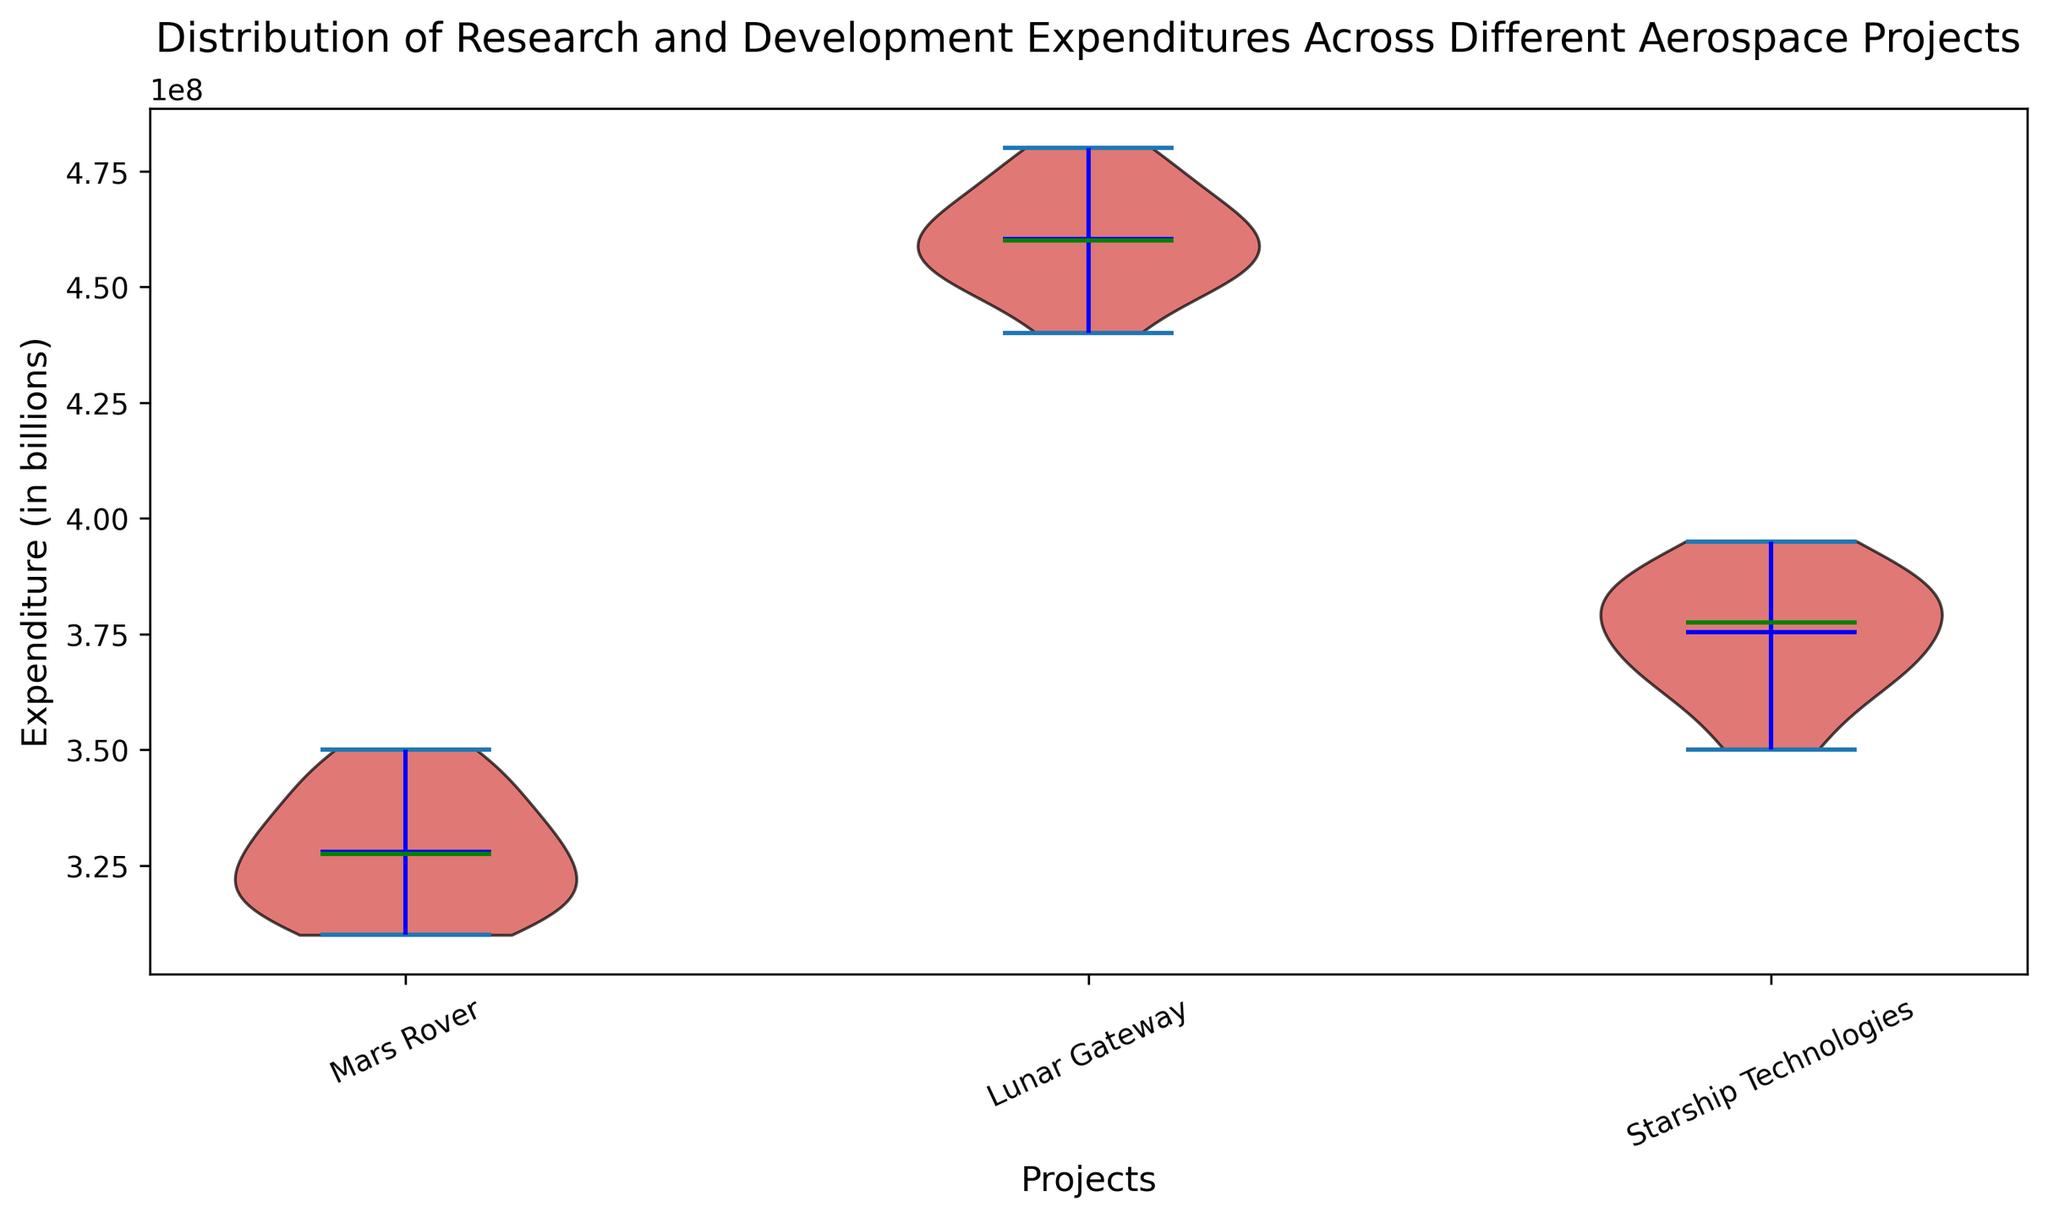What is the median expenditure for the Mars Rover project? Look for the green line that indicates the median within the violin plot section for the Mars Rover project.
Answer: $325,000,000 Which project shows the highest maximum expenditure value? Compare the heights of the violin plots for each project, particularly the uppermost points. The Lunar Gateway project has the highest uppermost point.
Answer: Lunar Gateway Does the Starship Technologies project have a higher mean expenditure than the Mars Rover project? The blue line signifies the mean expenditure. Compare the position of the blue line within the Starship Technologies plot to that within the Mars Rover plot.
Answer: Yes What is the range of expenditures for the Lunar Gateway project? Determine the lowest and highest points within the Lunar Gateway plot, then subtract the lowest expenditure from the highest. The range is $480,000,000 - $440,000,000.
Answer: $40,000,000 Which project is funded with the least variance? A narrower violin plot suggests less variance. Compare the widths of all three projects' plots.
Answer: Mars Rover Do all projects have overlapping expenditure distributions? Observe whether the different sections (width of the violins) of the plots intersect with each other.
Answer: Yes Which project has the lowest minimum expenditure value? Identify the lowest points across all the projects' plots. The Mars Rover project has the lowest minimum value.
Answer: Mars Rover How does the spread of expenditures for Lunar Gateway compare to Starship Technologies? The spread can be observed by the width and the height of the plots. Lunar Gateway has a wider and taller spread compared to Starship Technologies.
Answer: Lunar Gateway has a larger spread Is the median expenditure of the Lunar Gateway project closer to its minimum expenditure or maximum expenditure? Observe the position of the green median line relative to the vertical span of the plot for Lunar Gateway.
Answer: Closer to minimum What is the expenditure difference between the maximum of Starship Technologies and the median of Mars Rover? Subtract the median value of Mars Rover from the maximum value of Starship Technologies.
Answer: $395,000,000 - $325,000,000 = $70,000,000 